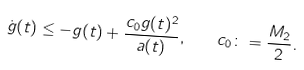Convert formula to latex. <formula><loc_0><loc_0><loc_500><loc_500>\dot { g } ( t ) \leq - g ( t ) + \frac { c _ { 0 } g ( t ) ^ { 2 } } { a ( t ) } , \quad c _ { 0 } \colon = \frac { M _ { 2 } } { 2 } .</formula> 